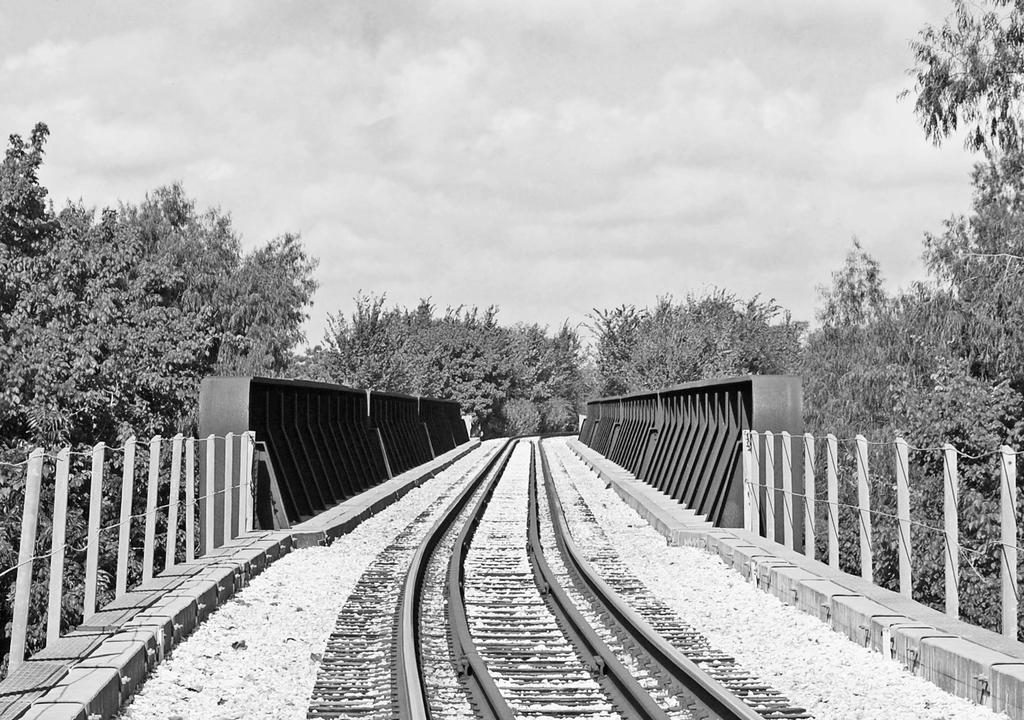What is located at the bottom of the image? There is a railway track at the bottom of the image. What surrounds the railway track? There is a fence on both sides of the railway track. What can be seen in the background of the image? There are trees and clouds in the sky in the background of the image. Can you see a boat sailing on the railway track in the image? No, there is no boat present in the image. The image features a railway track, fences, trees, and clouds in the sky. 